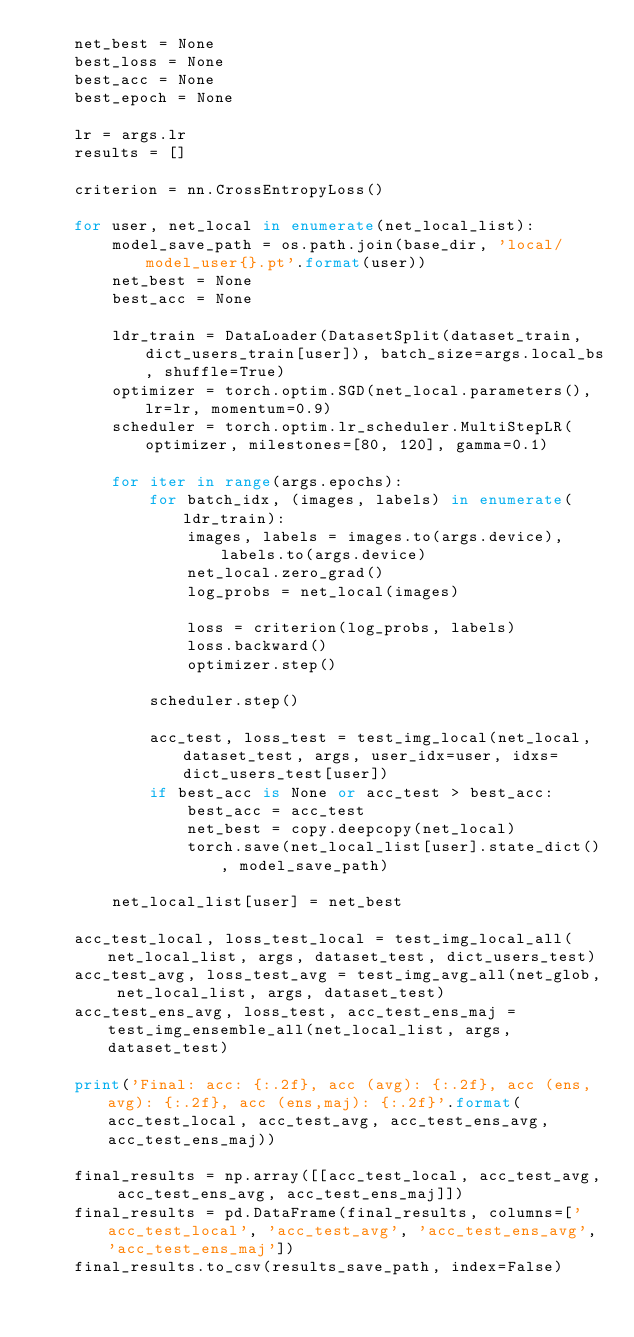<code> <loc_0><loc_0><loc_500><loc_500><_Python_>    net_best = None
    best_loss = None
    best_acc = None
    best_epoch = None

    lr = args.lr
    results = []

    criterion = nn.CrossEntropyLoss()

    for user, net_local in enumerate(net_local_list):
        model_save_path = os.path.join(base_dir, 'local/model_user{}.pt'.format(user))
        net_best = None
        best_acc = None

        ldr_train = DataLoader(DatasetSplit(dataset_train, dict_users_train[user]), batch_size=args.local_bs, shuffle=True)
        optimizer = torch.optim.SGD(net_local.parameters(), lr=lr, momentum=0.9)
        scheduler = torch.optim.lr_scheduler.MultiStepLR(optimizer, milestones=[80, 120], gamma=0.1)
        
        for iter in range(args.epochs):
            for batch_idx, (images, labels) in enumerate(ldr_train):
                images, labels = images.to(args.device), labels.to(args.device)
                net_local.zero_grad()
                log_probs = net_local(images)

                loss = criterion(log_probs, labels)
                loss.backward()
                optimizer.step()
                
            scheduler.step()
            
            acc_test, loss_test = test_img_local(net_local, dataset_test, args, user_idx=user, idxs=dict_users_test[user])
            if best_acc is None or acc_test > best_acc:
                best_acc = acc_test
                net_best = copy.deepcopy(net_local)
                torch.save(net_local_list[user].state_dict(), model_save_path)
            
        net_local_list[user] = net_best

    acc_test_local, loss_test_local = test_img_local_all(net_local_list, args, dataset_test, dict_users_test)
    acc_test_avg, loss_test_avg = test_img_avg_all(net_glob, net_local_list, args, dataset_test)
    acc_test_ens_avg, loss_test, acc_test_ens_maj = test_img_ensemble_all(net_local_list, args, dataset_test)

    print('Final: acc: {:.2f}, acc (avg): {:.2f}, acc (ens,avg): {:.2f}, acc (ens,maj): {:.2f}'.format(acc_test_local, acc_test_avg, acc_test_ens_avg, acc_test_ens_maj))

    final_results = np.array([[acc_test_local, acc_test_avg, acc_test_ens_avg, acc_test_ens_maj]])
    final_results = pd.DataFrame(final_results, columns=['acc_test_local', 'acc_test_avg', 'acc_test_ens_avg', 'acc_test_ens_maj'])
    final_results.to_csv(results_save_path, index=False)
</code> 